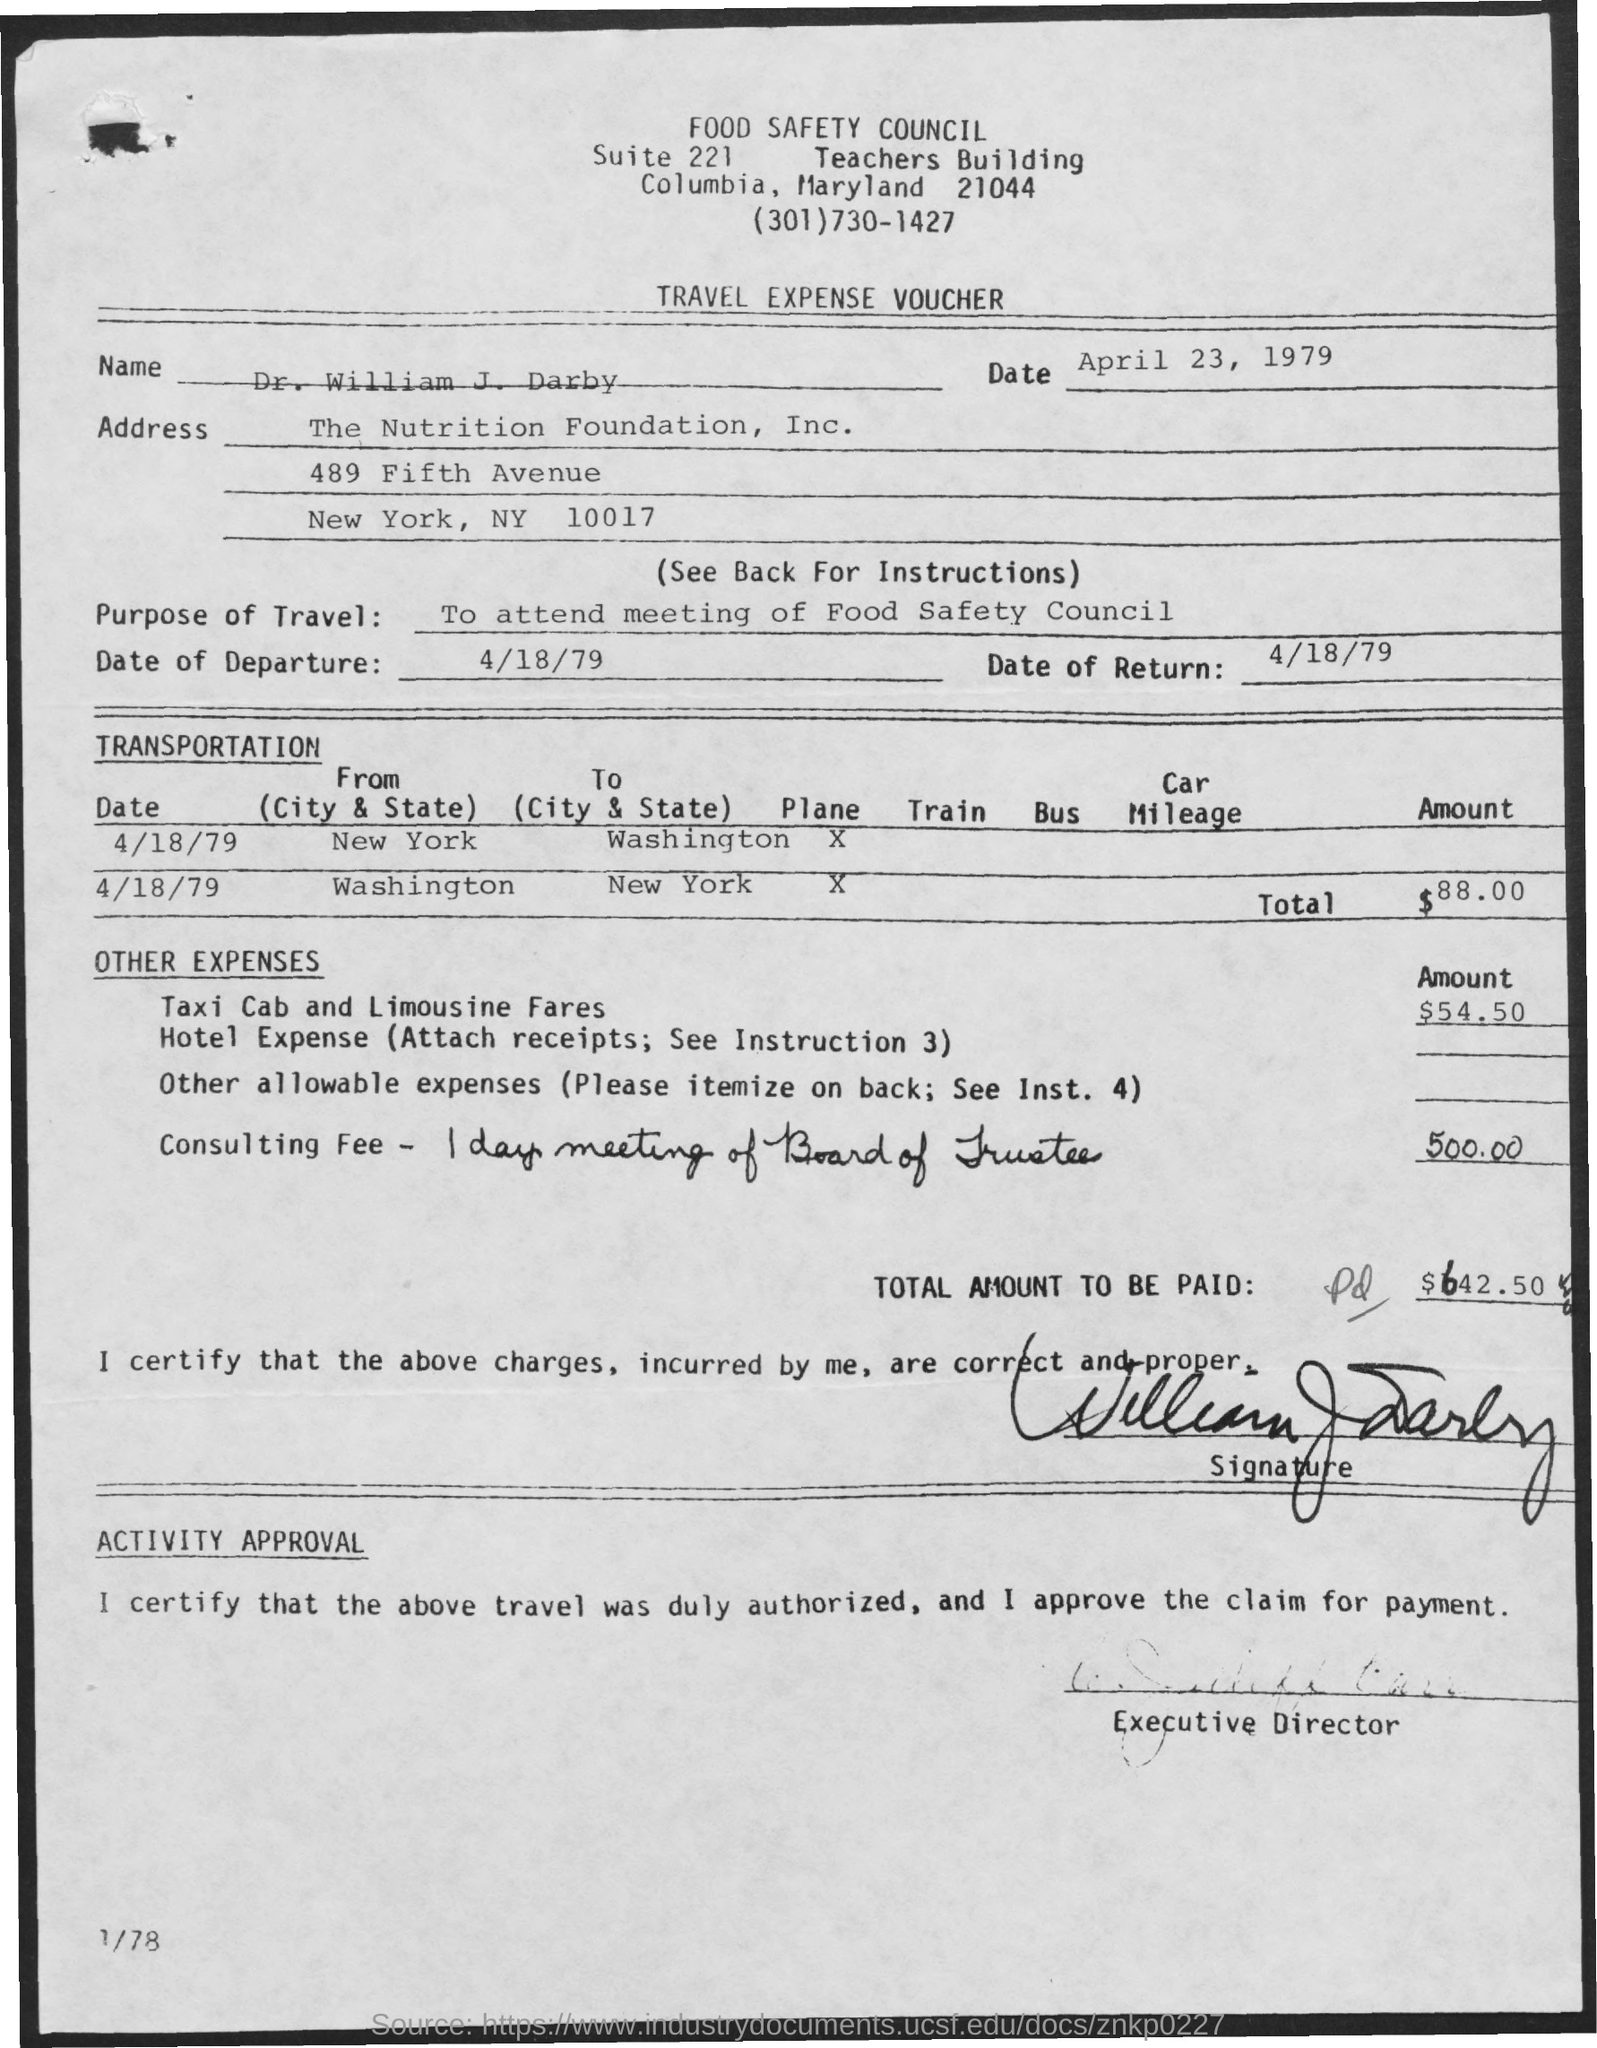Can you tell me what the purpose of the travel was? The traveler attended a meeting of the Food Safety Council. 